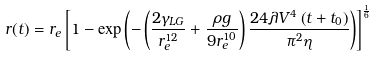<formula> <loc_0><loc_0><loc_500><loc_500>r ( t ) = r _ { e } \left [ 1 - \exp \left ( - \left ( { \frac { 2 \gamma _ { L G } } { r _ { e } ^ { 1 2 } } } + { \frac { \rho g } { 9 r _ { e } ^ { 1 0 } } } \right ) { \frac { 2 4 \lambda V ^ { 4 } \left ( t + t _ { 0 } \right ) } { \pi ^ { 2 } \eta } } \right ) \right ] ^ { \frac { 1 } { 6 } }</formula> 